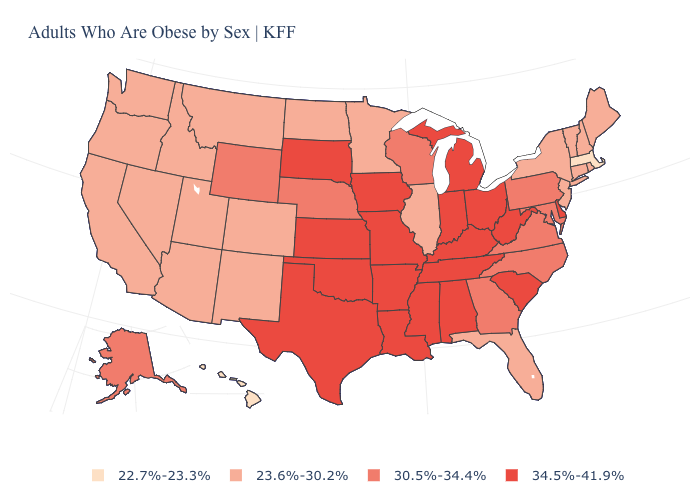Which states have the highest value in the USA?
Keep it brief. Alabama, Arkansas, Delaware, Indiana, Iowa, Kansas, Kentucky, Louisiana, Michigan, Mississippi, Missouri, Ohio, Oklahoma, South Carolina, South Dakota, Tennessee, Texas, West Virginia. Does Maine have a lower value than Oklahoma?
Short answer required. Yes. What is the value of Alaska?
Give a very brief answer. 30.5%-34.4%. What is the value of Alabama?
Keep it brief. 34.5%-41.9%. What is the value of West Virginia?
Write a very short answer. 34.5%-41.9%. What is the lowest value in states that border California?
Give a very brief answer. 23.6%-30.2%. What is the value of Maryland?
Keep it brief. 30.5%-34.4%. Among the states that border Arizona , which have the lowest value?
Be succinct. California, Colorado, Nevada, New Mexico, Utah. What is the lowest value in the USA?
Quick response, please. 22.7%-23.3%. What is the lowest value in the Northeast?
Concise answer only. 22.7%-23.3%. What is the value of California?
Quick response, please. 23.6%-30.2%. Does Oklahoma have a higher value than Alaska?
Short answer required. Yes. Name the states that have a value in the range 22.7%-23.3%?
Answer briefly. Hawaii, Massachusetts. Name the states that have a value in the range 34.5%-41.9%?
Concise answer only. Alabama, Arkansas, Delaware, Indiana, Iowa, Kansas, Kentucky, Louisiana, Michigan, Mississippi, Missouri, Ohio, Oklahoma, South Carolina, South Dakota, Tennessee, Texas, West Virginia. Which states have the highest value in the USA?
Concise answer only. Alabama, Arkansas, Delaware, Indiana, Iowa, Kansas, Kentucky, Louisiana, Michigan, Mississippi, Missouri, Ohio, Oklahoma, South Carolina, South Dakota, Tennessee, Texas, West Virginia. 